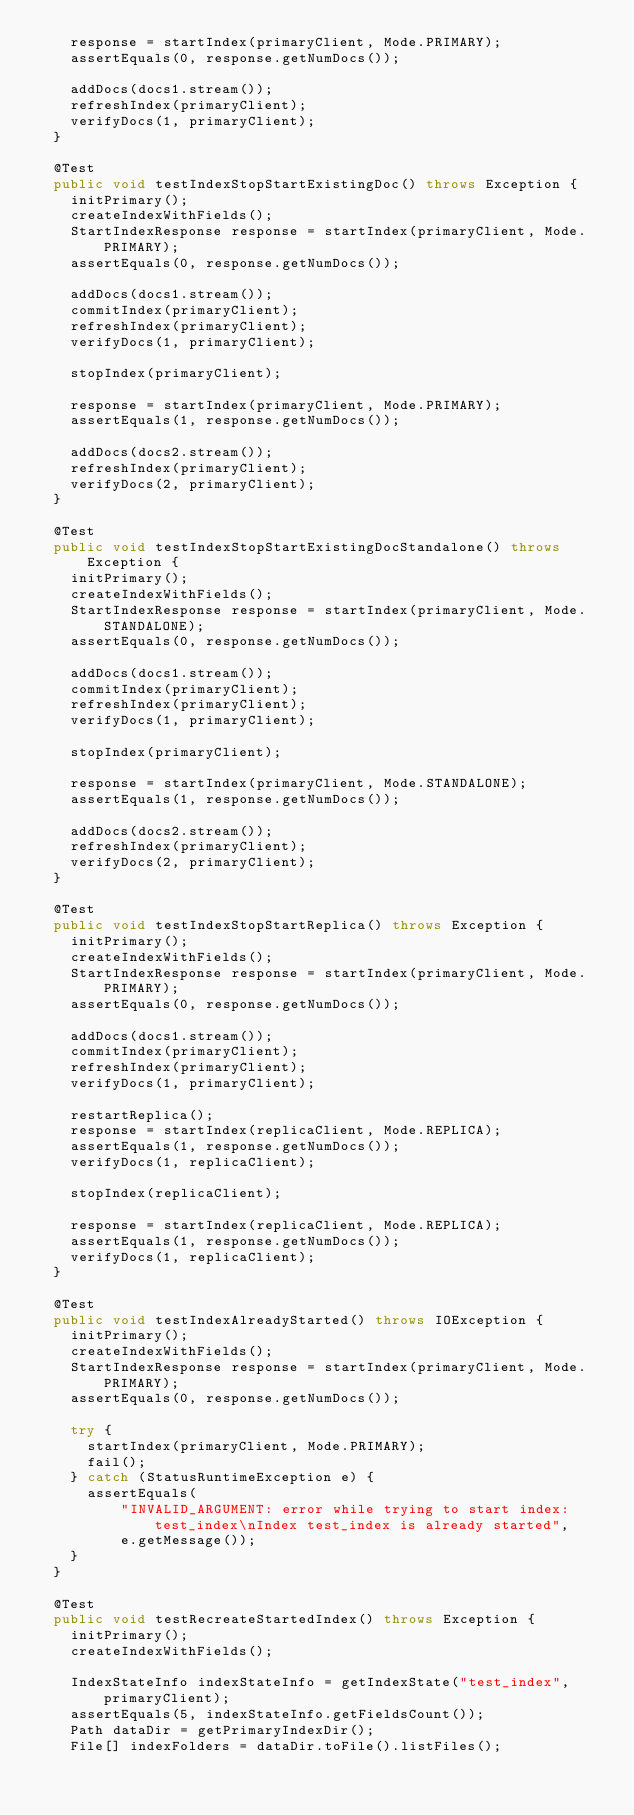<code> <loc_0><loc_0><loc_500><loc_500><_Java_>    response = startIndex(primaryClient, Mode.PRIMARY);
    assertEquals(0, response.getNumDocs());

    addDocs(docs1.stream());
    refreshIndex(primaryClient);
    verifyDocs(1, primaryClient);
  }

  @Test
  public void testIndexStopStartExistingDoc() throws Exception {
    initPrimary();
    createIndexWithFields();
    StartIndexResponse response = startIndex(primaryClient, Mode.PRIMARY);
    assertEquals(0, response.getNumDocs());

    addDocs(docs1.stream());
    commitIndex(primaryClient);
    refreshIndex(primaryClient);
    verifyDocs(1, primaryClient);

    stopIndex(primaryClient);

    response = startIndex(primaryClient, Mode.PRIMARY);
    assertEquals(1, response.getNumDocs());

    addDocs(docs2.stream());
    refreshIndex(primaryClient);
    verifyDocs(2, primaryClient);
  }

  @Test
  public void testIndexStopStartExistingDocStandalone() throws Exception {
    initPrimary();
    createIndexWithFields();
    StartIndexResponse response = startIndex(primaryClient, Mode.STANDALONE);
    assertEquals(0, response.getNumDocs());

    addDocs(docs1.stream());
    commitIndex(primaryClient);
    refreshIndex(primaryClient);
    verifyDocs(1, primaryClient);

    stopIndex(primaryClient);

    response = startIndex(primaryClient, Mode.STANDALONE);
    assertEquals(1, response.getNumDocs());

    addDocs(docs2.stream());
    refreshIndex(primaryClient);
    verifyDocs(2, primaryClient);
  }

  @Test
  public void testIndexStopStartReplica() throws Exception {
    initPrimary();
    createIndexWithFields();
    StartIndexResponse response = startIndex(primaryClient, Mode.PRIMARY);
    assertEquals(0, response.getNumDocs());

    addDocs(docs1.stream());
    commitIndex(primaryClient);
    refreshIndex(primaryClient);
    verifyDocs(1, primaryClient);

    restartReplica();
    response = startIndex(replicaClient, Mode.REPLICA);
    assertEquals(1, response.getNumDocs());
    verifyDocs(1, replicaClient);

    stopIndex(replicaClient);

    response = startIndex(replicaClient, Mode.REPLICA);
    assertEquals(1, response.getNumDocs());
    verifyDocs(1, replicaClient);
  }

  @Test
  public void testIndexAlreadyStarted() throws IOException {
    initPrimary();
    createIndexWithFields();
    StartIndexResponse response = startIndex(primaryClient, Mode.PRIMARY);
    assertEquals(0, response.getNumDocs());

    try {
      startIndex(primaryClient, Mode.PRIMARY);
      fail();
    } catch (StatusRuntimeException e) {
      assertEquals(
          "INVALID_ARGUMENT: error while trying to start index: test_index\nIndex test_index is already started",
          e.getMessage());
    }
  }

  @Test
  public void testRecreateStartedIndex() throws Exception {
    initPrimary();
    createIndexWithFields();

    IndexStateInfo indexStateInfo = getIndexState("test_index", primaryClient);
    assertEquals(5, indexStateInfo.getFieldsCount());
    Path dataDir = getPrimaryIndexDir();
    File[] indexFolders = dataDir.toFile().listFiles();</code> 